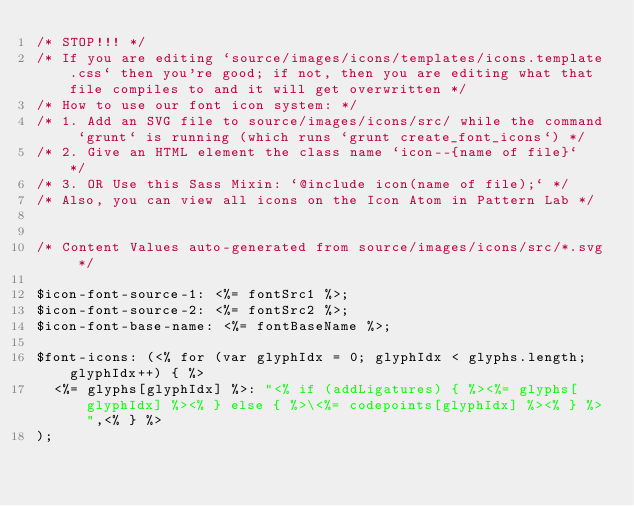Convert code to text. <code><loc_0><loc_0><loc_500><loc_500><_CSS_>/* STOP!!! */
/* If you are editing `source/images/icons/templates/icons.template.css` then you're good; if not, then you are editing what that file compiles to and it will get overwritten */
/* How to use our font icon system: */
/* 1. Add an SVG file to source/images/icons/src/ while the command `grunt` is running (which runs `grunt create_font_icons`) */
/* 2. Give an HTML element the class name `icon--{name of file}`  */
/* 3. OR Use this Sass Mixin: `@include icon(name of file);` */
/* Also, you can view all icons on the Icon Atom in Pattern Lab */


/* Content Values auto-generated from source/images/icons/src/*.svg */

$icon-font-source-1: <%= fontSrc1 %>;
$icon-font-source-2: <%= fontSrc2 %>;
$icon-font-base-name: <%= fontBaseName %>;

$font-icons: (<% for (var glyphIdx = 0; glyphIdx < glyphs.length; glyphIdx++) { %>
  <%= glyphs[glyphIdx] %>: "<% if (addLigatures) { %><%= glyphs[glyphIdx] %><% } else { %>\<%= codepoints[glyphIdx] %><% } %>",<% } %>
);
</code> 